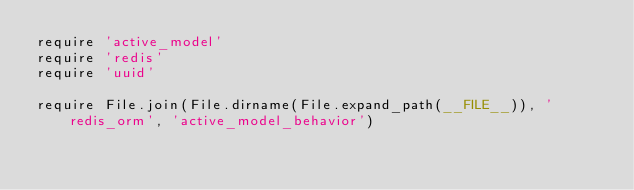<code> <loc_0><loc_0><loc_500><loc_500><_Ruby_>require 'active_model'
require 'redis'
require 'uuid'

require File.join(File.dirname(File.expand_path(__FILE__)), 'redis_orm', 'active_model_behavior')</code> 